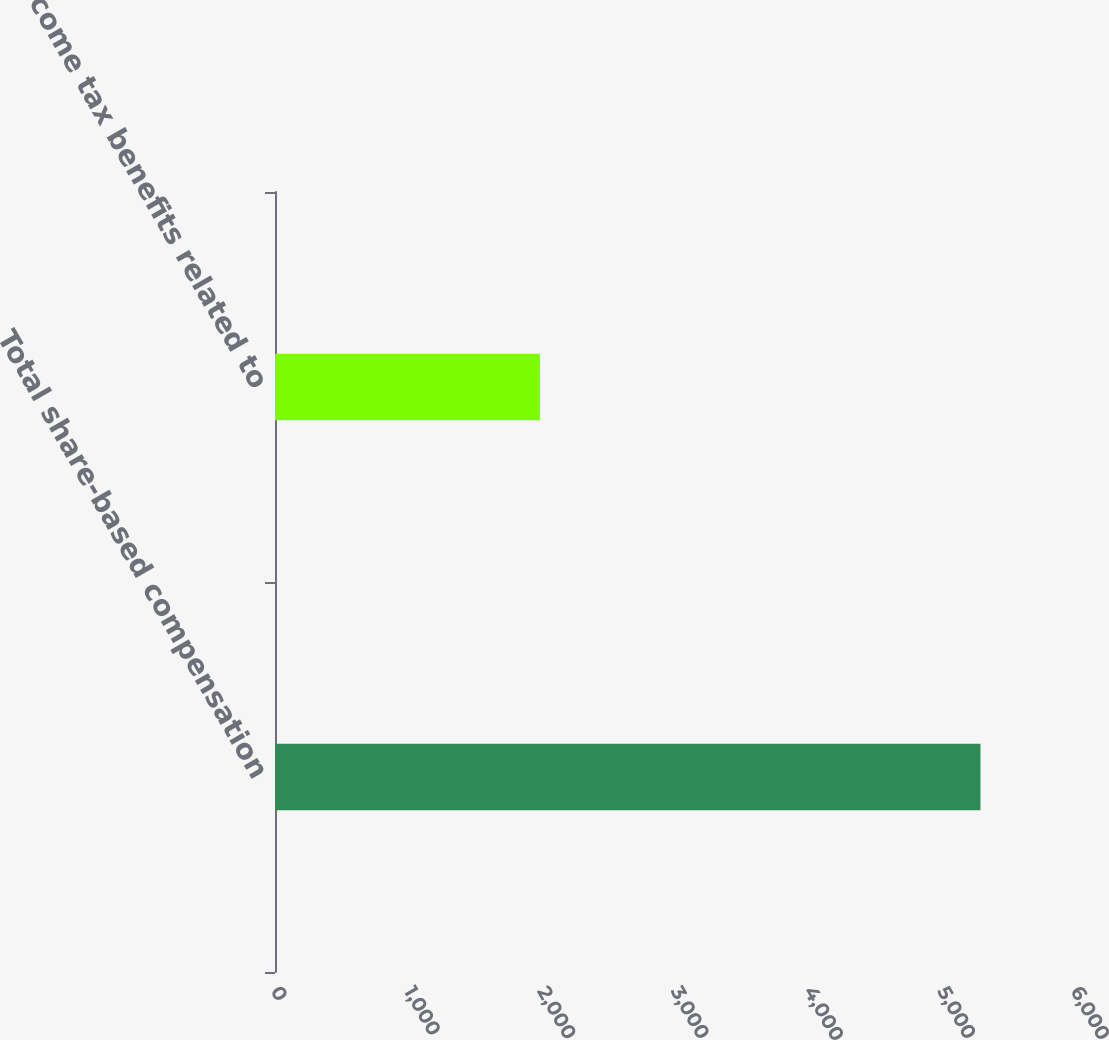<chart> <loc_0><loc_0><loc_500><loc_500><bar_chart><fcel>Total share-based compensation<fcel>Income tax benefits related to<nl><fcel>5291<fcel>1987<nl></chart> 